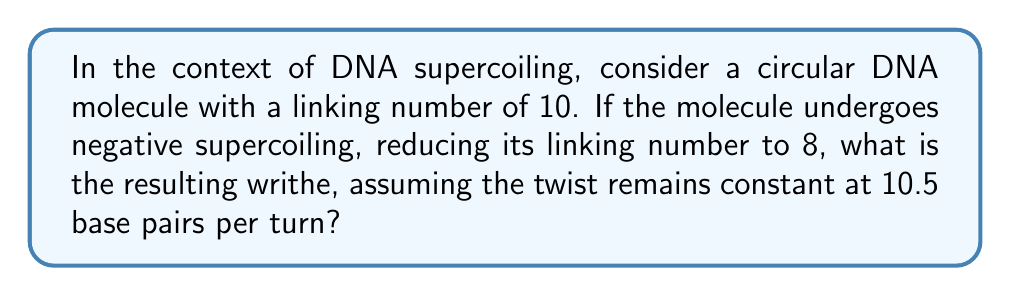Show me your answer to this math problem. To solve this problem, we need to understand the relationship between linking number, twist, and writhe in DNA topology. The fundamental equation in DNA topology is:

$$ Lk = Tw + Wr $$

Where:
$Lk$ = Linking number
$Tw$ = Twist
$Wr$ = Writhe

Step 1: Determine the initial twist.
The twist is the number of helical turns in the DNA. Given that there are 10.5 base pairs per turn:
$$ Tw_initial = \frac{10 \times 10.5}{10.5} = 10 $$

Step 2: Calculate the change in linking number.
$$ \Delta Lk = Lk_{final} - Lk_{initial} = 8 - 10 = -2 $$

Step 3: Use the conservation of linking number.
Since the twist remains constant, the change in linking number must be accommodated by the writhe:
$$ \Delta Lk = \Delta Tw + \Delta Wr $$
$$ -2 = 0 + \Delta Wr $$
$$ \Delta Wr = -2 $$

Step 4: Calculate the final writhe.
The initial writhe was 0 (relaxed circular DNA), so:
$$ Wr_{final} = Wr_{initial} + \Delta Wr = 0 + (-2) = -2 $$

Therefore, the resulting writhe is -2.
Answer: -2 